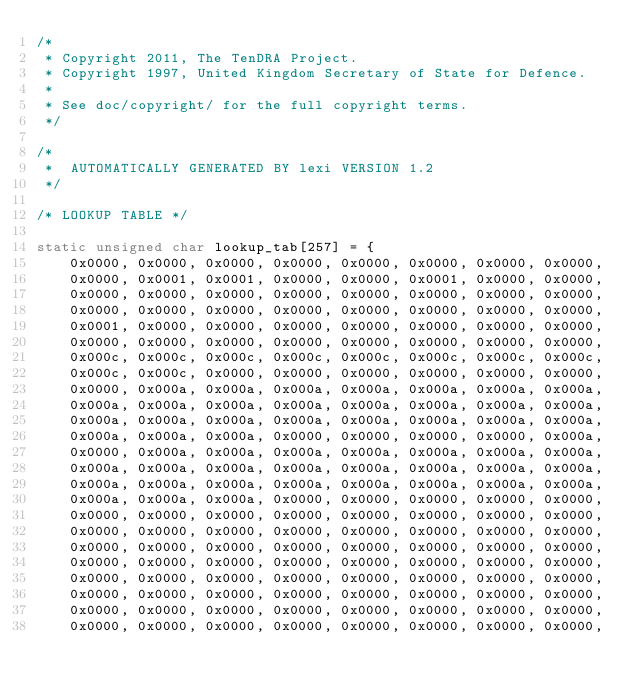<code> <loc_0><loc_0><loc_500><loc_500><_C_>/*
 * Copyright 2011, The TenDRA Project.
 * Copyright 1997, United Kingdom Secretary of State for Defence.
 *
 * See doc/copyright/ for the full copyright terms.
 */

/*
 *  AUTOMATICALLY GENERATED BY lexi VERSION 1.2
 */

/* LOOKUP TABLE */

static unsigned char lookup_tab[257] = {
    0x0000, 0x0000, 0x0000, 0x0000, 0x0000, 0x0000, 0x0000, 0x0000,
    0x0000, 0x0001, 0x0001, 0x0000, 0x0000, 0x0001, 0x0000, 0x0000,
    0x0000, 0x0000, 0x0000, 0x0000, 0x0000, 0x0000, 0x0000, 0x0000,
    0x0000, 0x0000, 0x0000, 0x0000, 0x0000, 0x0000, 0x0000, 0x0000,
    0x0001, 0x0000, 0x0000, 0x0000, 0x0000, 0x0000, 0x0000, 0x0000,
    0x0000, 0x0000, 0x0000, 0x0000, 0x0000, 0x0000, 0x0000, 0x0000,
    0x000c, 0x000c, 0x000c, 0x000c, 0x000c, 0x000c, 0x000c, 0x000c,
    0x000c, 0x000c, 0x0000, 0x0000, 0x0000, 0x0000, 0x0000, 0x0000,
    0x0000, 0x000a, 0x000a, 0x000a, 0x000a, 0x000a, 0x000a, 0x000a,
    0x000a, 0x000a, 0x000a, 0x000a, 0x000a, 0x000a, 0x000a, 0x000a,
    0x000a, 0x000a, 0x000a, 0x000a, 0x000a, 0x000a, 0x000a, 0x000a,
    0x000a, 0x000a, 0x000a, 0x0000, 0x0000, 0x0000, 0x0000, 0x000a,
    0x0000, 0x000a, 0x000a, 0x000a, 0x000a, 0x000a, 0x000a, 0x000a,
    0x000a, 0x000a, 0x000a, 0x000a, 0x000a, 0x000a, 0x000a, 0x000a,
    0x000a, 0x000a, 0x000a, 0x000a, 0x000a, 0x000a, 0x000a, 0x000a,
    0x000a, 0x000a, 0x000a, 0x0000, 0x0000, 0x0000, 0x0000, 0x0000,
    0x0000, 0x0000, 0x0000, 0x0000, 0x0000, 0x0000, 0x0000, 0x0000,
    0x0000, 0x0000, 0x0000, 0x0000, 0x0000, 0x0000, 0x0000, 0x0000,
    0x0000, 0x0000, 0x0000, 0x0000, 0x0000, 0x0000, 0x0000, 0x0000,
    0x0000, 0x0000, 0x0000, 0x0000, 0x0000, 0x0000, 0x0000, 0x0000,
    0x0000, 0x0000, 0x0000, 0x0000, 0x0000, 0x0000, 0x0000, 0x0000,
    0x0000, 0x0000, 0x0000, 0x0000, 0x0000, 0x0000, 0x0000, 0x0000,
    0x0000, 0x0000, 0x0000, 0x0000, 0x0000, 0x0000, 0x0000, 0x0000,
    0x0000, 0x0000, 0x0000, 0x0000, 0x0000, 0x0000, 0x0000, 0x0000,</code> 